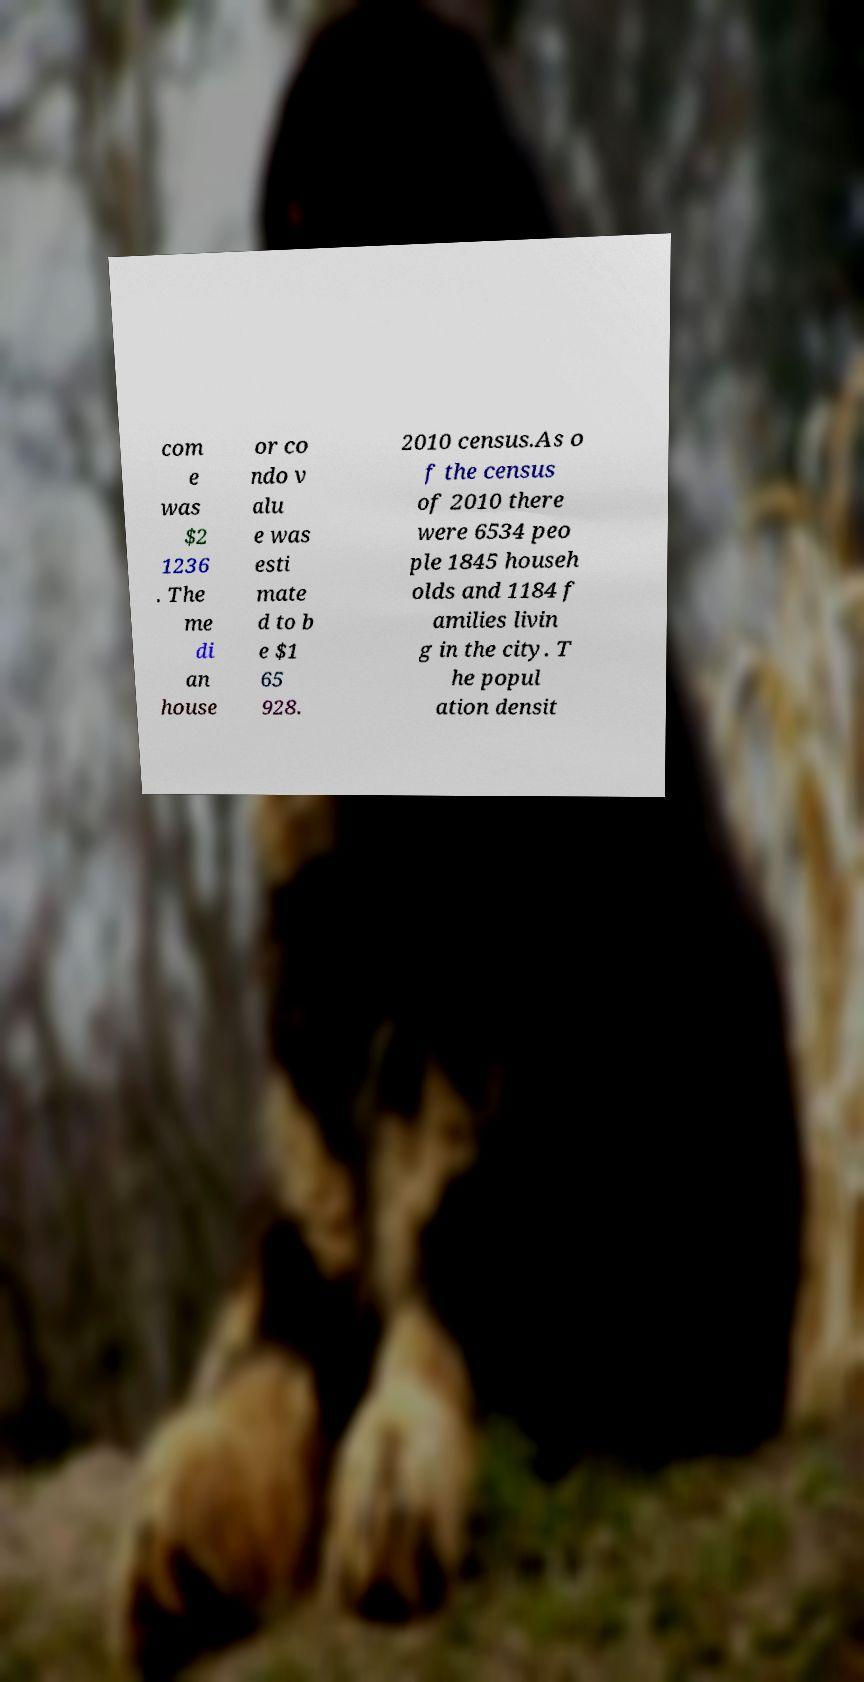Could you extract and type out the text from this image? com e was $2 1236 . The me di an house or co ndo v alu e was esti mate d to b e $1 65 928. 2010 census.As o f the census of 2010 there were 6534 peo ple 1845 househ olds and 1184 f amilies livin g in the city. T he popul ation densit 